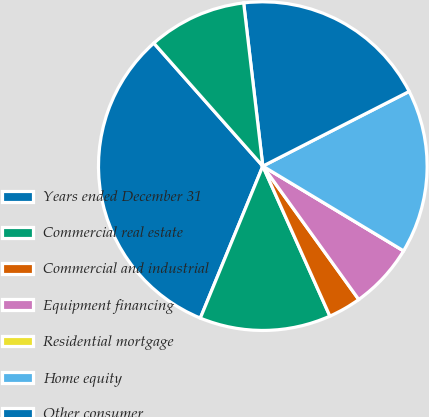Convert chart. <chart><loc_0><loc_0><loc_500><loc_500><pie_chart><fcel>Years ended December 31<fcel>Commercial real estate<fcel>Commercial and industrial<fcel>Equipment financing<fcel>Residential mortgage<fcel>Home equity<fcel>Other consumer<fcel>Total portfolio<nl><fcel>32.25%<fcel>12.9%<fcel>3.23%<fcel>6.45%<fcel>0.0%<fcel>16.13%<fcel>19.35%<fcel>9.68%<nl></chart> 